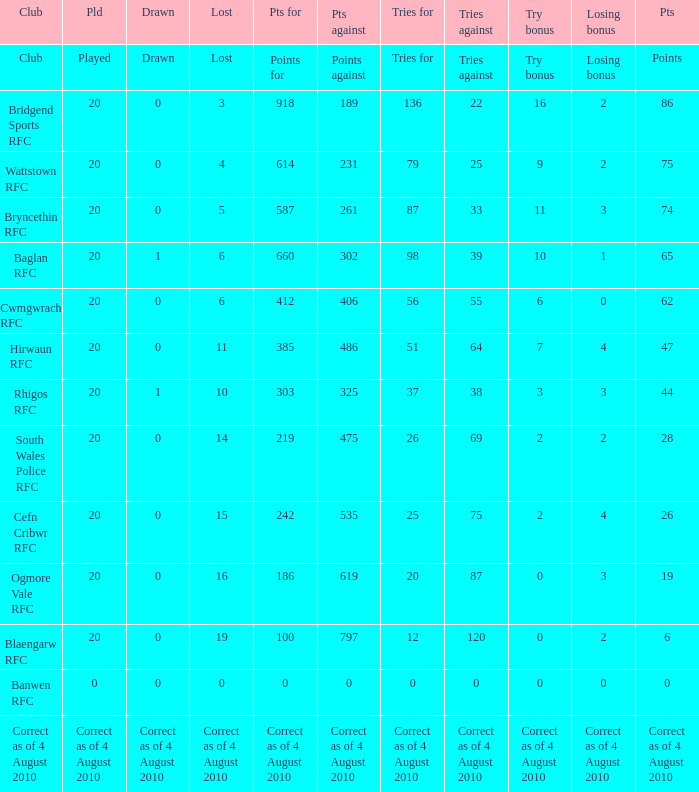What is the tries fow when losing bonus is losing bonus? Tries for. 